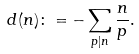<formula> <loc_0><loc_0><loc_500><loc_500>d ( n ) \colon = - \sum _ { p | n } \frac { n } { p } .</formula> 